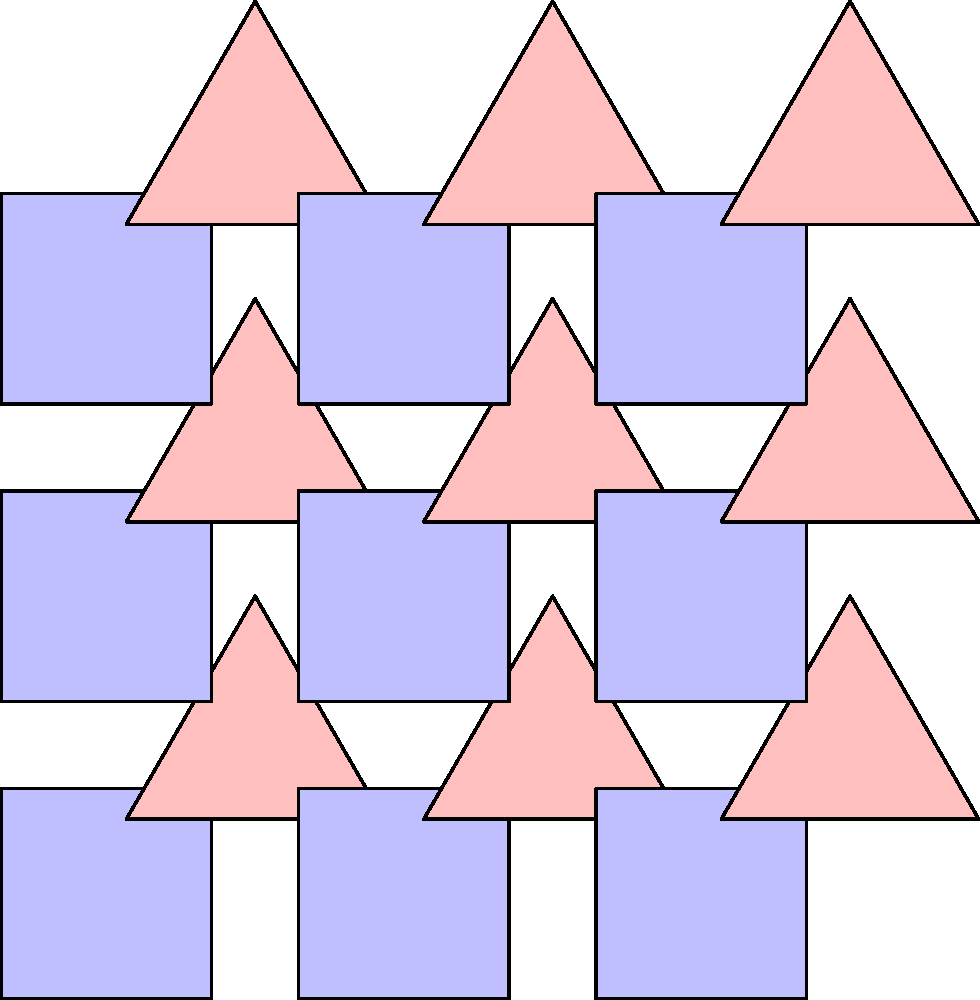In the context of traditional family quilt patterns, which wallpaper group does the tessellation shown in the image most closely resemble, and how does this relate to the concept of family unity? To answer this question, let's analyze the tessellation step-by-step:

1. Observe the pattern: The tessellation consists of alternating squares and triangles arranged in a regular grid.

2. Identify symmetries:
   a) Rotation: The pattern has 4-fold rotational symmetry around the center of each square.
   b) Reflection: There are vertical and horizontal reflection lines passing through the centers of the squares.
   c) Translation: The pattern repeats by shifting horizontally and vertically.

3. Determine the wallpaper group: Based on these symmetries, this tessellation most closely resembles the p4m wallpaper group.

4. Relation to family unity:
   a) The regular, repeating pattern symbolizes stability and consistency in family life.
   b) The interlocking shapes represent how family members support and complement each other.
   c) The balance between squares (representing structure) and triangles (representing strength) reflects the importance of both stability and adaptability in family relationships.
   d) The overall symmetry of the pattern emphasizes the idea of equality and mutual respect among family members.

5. Family virtues connection:
   a) Consistency: The repeating pattern reinforces the importance of consistent values and routines in family life.
   b) Cooperation: The interlocking shapes demonstrate how family members work together harmoniously.
   c) Balance: The equal representation of squares and triangles highlights the need for balance in family roles and responsibilities.
   d) Unity: The overall tessellation creates a cohesive whole, symbolizing family unity despite individual differences.
Answer: p4m wallpaper group; symbolizes stability, cooperation, and unity in family life 